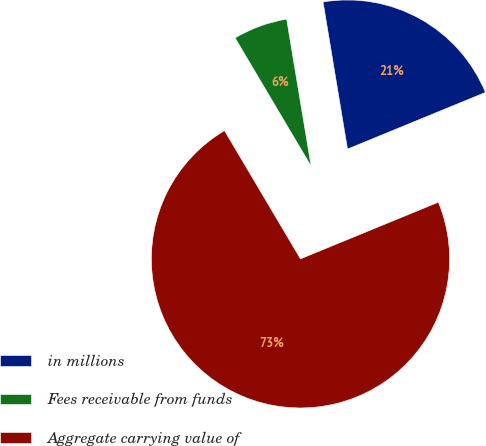Convert chart to OTSL. <chart><loc_0><loc_0><loc_500><loc_500><pie_chart><fcel>in millions<fcel>Fees receivable from funds<fcel>Aggregate carrying value of<nl><fcel>21.42%<fcel>5.89%<fcel>72.69%<nl></chart> 